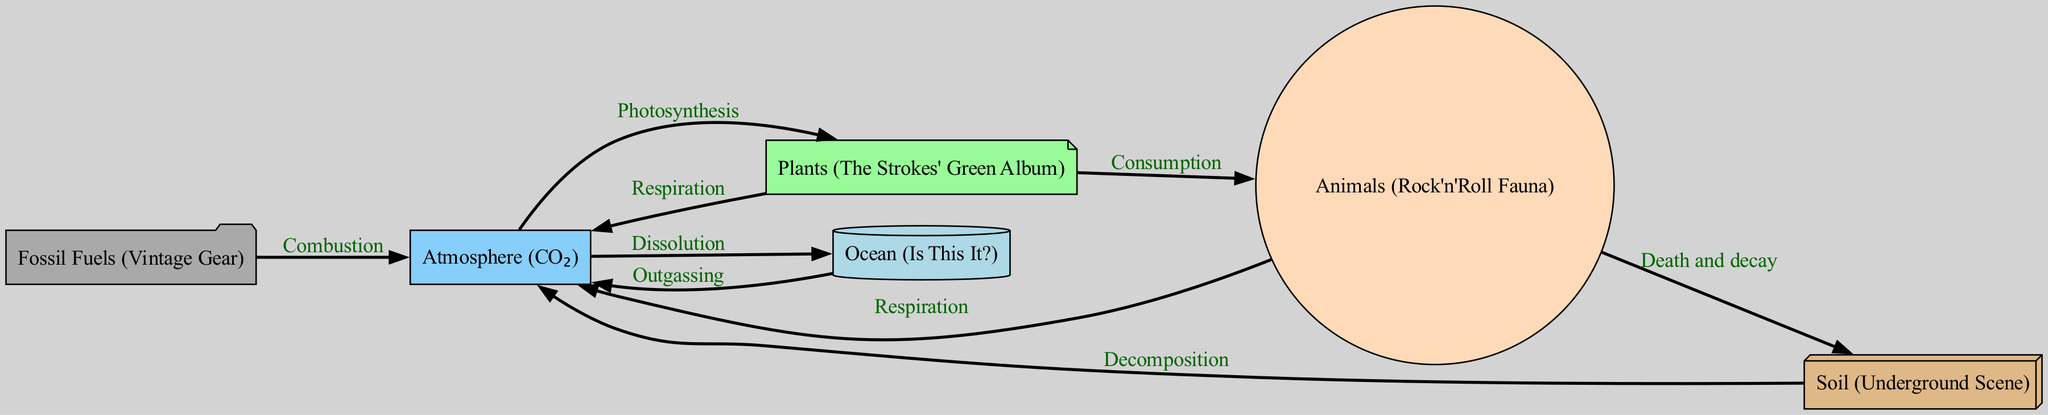What is the main process by which carbon enters plants from the atmosphere? The diagram indicates that carbon enters plants from the atmosphere through the process labeled "Photosynthesis." This is represented by a directed edge from the atmosphere node to the plants node.
Answer: Photosynthesis How many nodes are present in the diagram? The nodes in the diagram represent distinct components of the carbon cycle: atmosphere, plants, animals, soil, ocean, and fossil fuels. By counting these, we identify a total of six nodes.
Answer: 6 What do animals release back into the atmosphere? The diagram shows that animals release carbon back into the atmosphere through the process labeled "Respiration," represented by a directed edge from the animals node to the atmosphere node.
Answer: Respiration Which process connects animals to soil? According to the diagram, animals contribute to the soil through "Death and decay," as indicated by an edge from the animals node to the soil node. This provides a pathway for carbon to return to the soil.
Answer: Death and decay Which two processes show the interaction between the ocean and the atmosphere? The diagram vividly illustrates two processes: "Dissolution," where carbon moves from the atmosphere to the ocean, and "Outgassing," where carbon moves from the ocean to the atmosphere. Both processes highlight the exchange of carbon between these two nodes.
Answer: Dissolution and Outgassing 